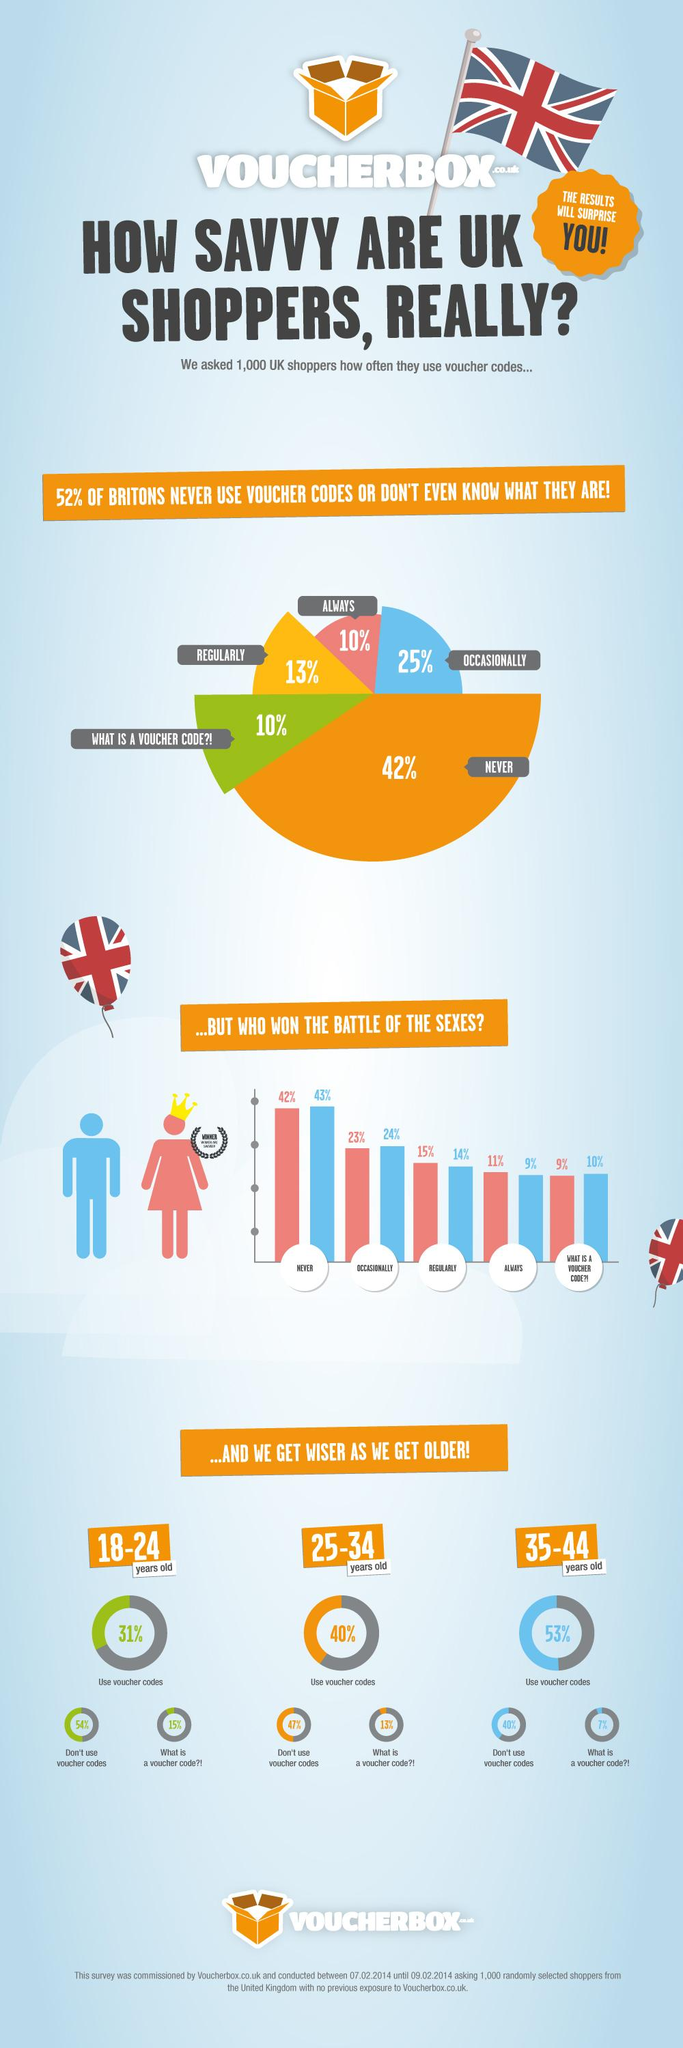Indicate a few pertinent items in this graphic. The gender that uses voucher codes the most is women. According to the survey, 15% of 18-24 year olds are not aware of voucher codes. A majority of shoppers, 48%, regularly use voucher codes, sometimes using them always or occasionally. According to a recent study, 7% of 35-44 year olds do not know what a voucher code is. According to the data, there is a 7% difference in the percentage of 25-34 year olds who use and do not use voucher codes. 